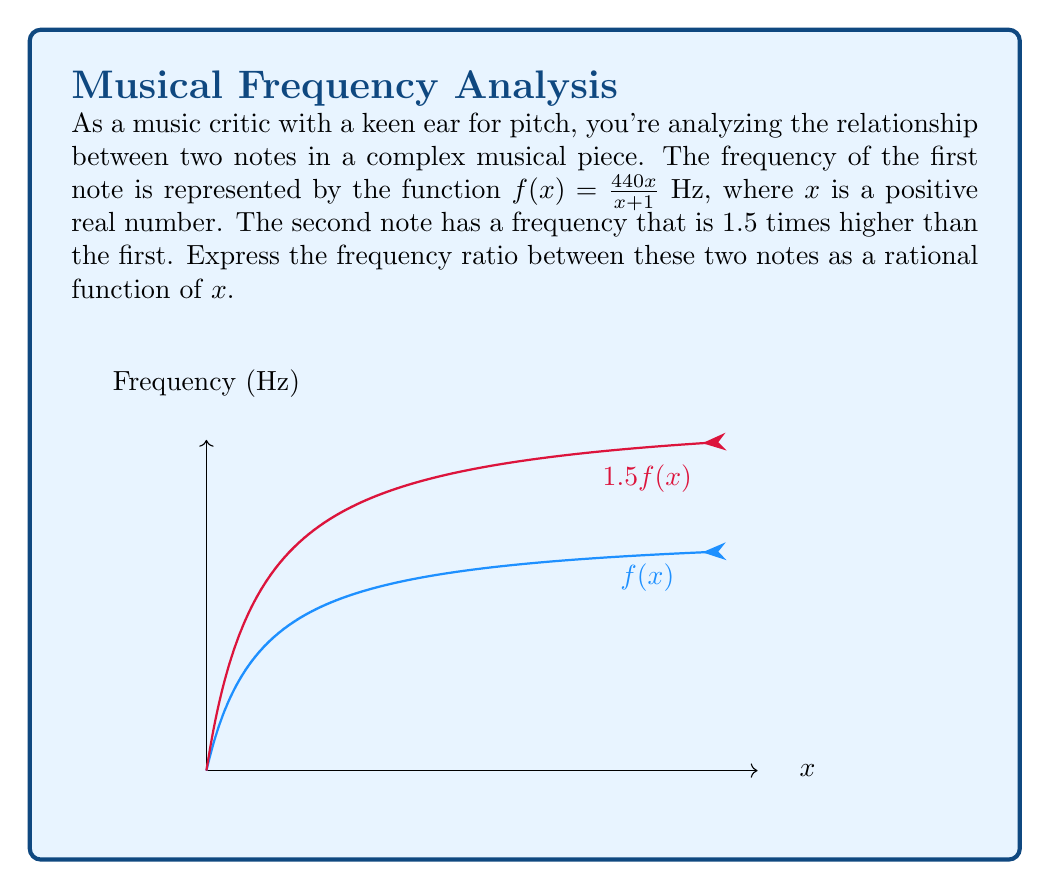Give your solution to this math problem. Let's approach this step-by-step:

1) The frequency of the first note is given by $f(x) = \frac{440x}{x+1}$ Hz.

2) The second note has a frequency that is 1.5 times higher than the first. We can represent this as:
   $g(x) = 1.5f(x) = 1.5 \cdot \frac{440x}{x+1} = \frac{660x}{x+1}$ Hz

3) To find the frequency ratio, we need to divide the frequency of the second note by the frequency of the first note:

   $$\text{Ratio} = \frac{g(x)}{f(x)} = \frac{\frac{660x}{x+1}}{\frac{440x}{x+1}}$$

4) We can simplify this fraction:

   $$\frac{\frac{660x}{x+1}}{\frac{440x}{x+1}} = \frac{660x}{440x} \cdot \frac{x+1}{x+1}$$

5) The $(x+1)$ terms cancel out:

   $$\frac{660x}{440x} = \frac{660}{440} = \frac{3}{2} = 1.5$$

6) Therefore, the frequency ratio between these two notes is a constant 1.5, regardless of the value of $x$.

This ratio of 3:2 (or 1.5:1) is known in music theory as a perfect fifth, one of the most consonant harmonic intervals.
Answer: $\frac{3}{2}$ 